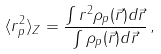<formula> <loc_0><loc_0><loc_500><loc_500>\langle r _ { p } ^ { 2 } \rangle _ { Z } = \frac { \int r ^ { 2 } \rho _ { p } ( { \vec { r } } ) d { \vec { r } } } { \int \rho _ { p } ( { \vec { r } } ) d { \vec { r } } } \, ,</formula> 